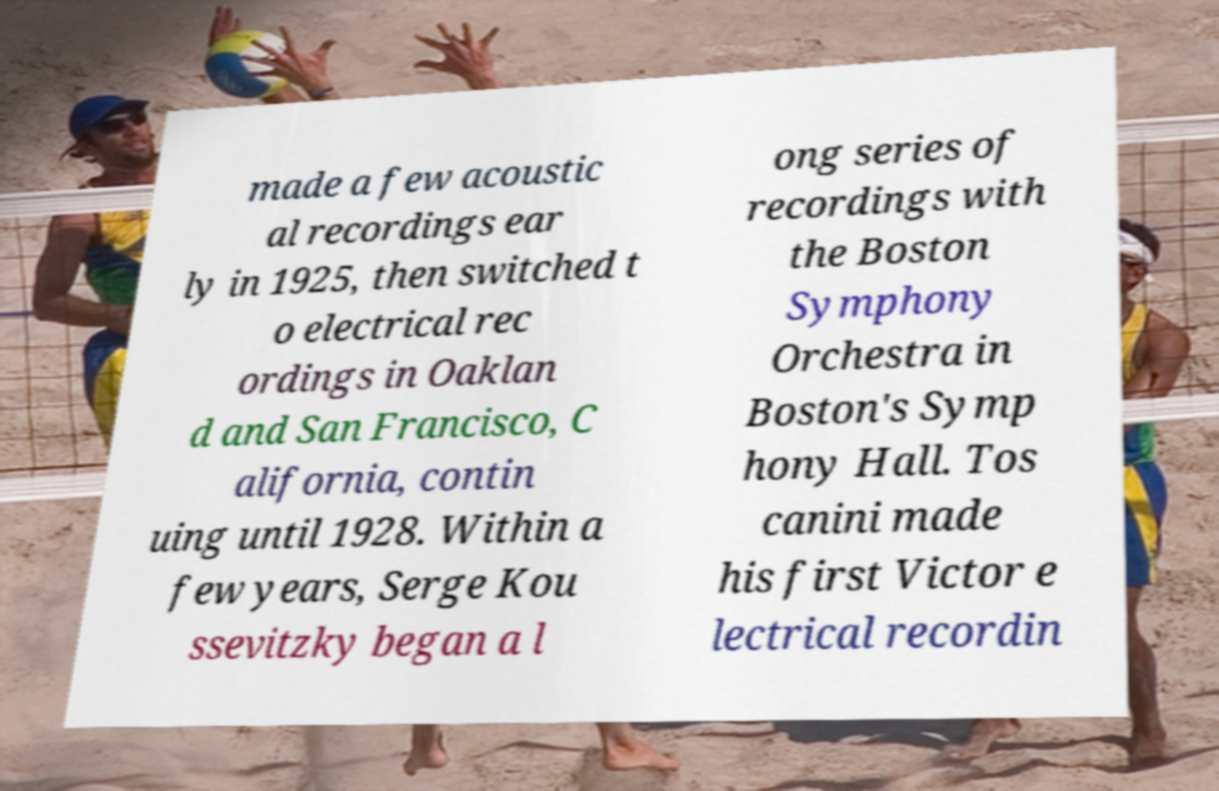I need the written content from this picture converted into text. Can you do that? made a few acoustic al recordings ear ly in 1925, then switched t o electrical rec ordings in Oaklan d and San Francisco, C alifornia, contin uing until 1928. Within a few years, Serge Kou ssevitzky began a l ong series of recordings with the Boston Symphony Orchestra in Boston's Symp hony Hall. Tos canini made his first Victor e lectrical recordin 